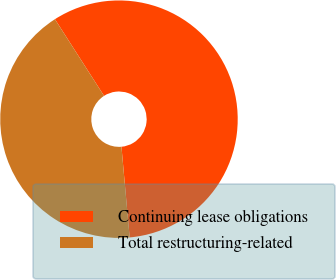Convert chart to OTSL. <chart><loc_0><loc_0><loc_500><loc_500><pie_chart><fcel>Continuing lease obligations<fcel>Total restructuring-related<nl><fcel>57.63%<fcel>42.37%<nl></chart> 